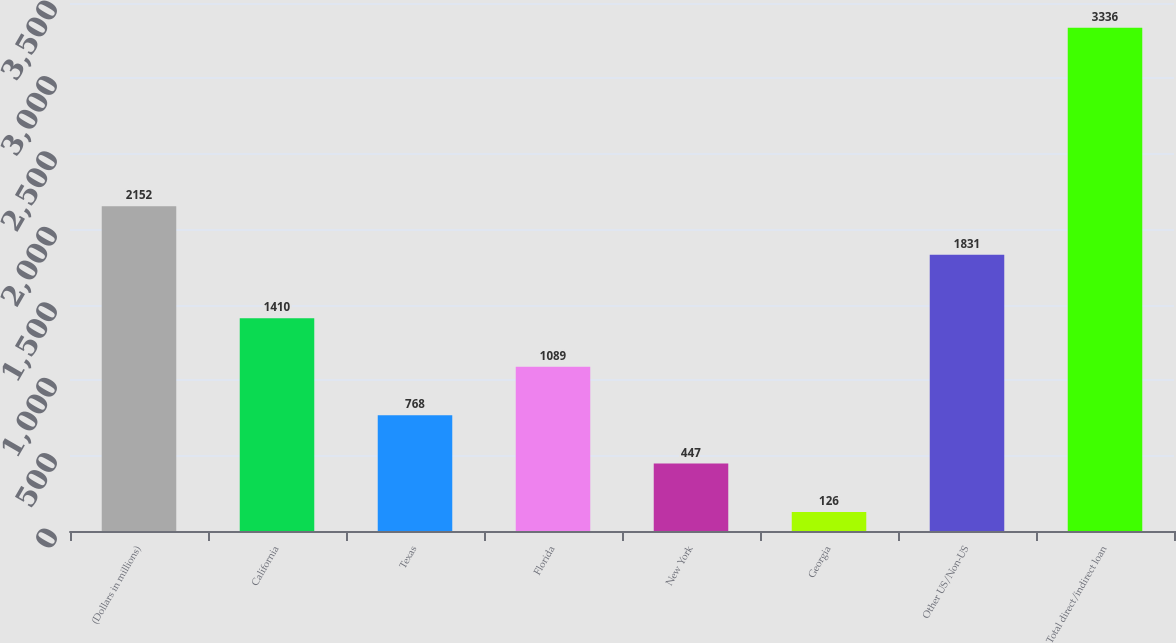Convert chart. <chart><loc_0><loc_0><loc_500><loc_500><bar_chart><fcel>(Dollars in millions)<fcel>California<fcel>Texas<fcel>Florida<fcel>New York<fcel>Georgia<fcel>Other US/Non-US<fcel>Total direct/indirect loan<nl><fcel>2152<fcel>1410<fcel>768<fcel>1089<fcel>447<fcel>126<fcel>1831<fcel>3336<nl></chart> 